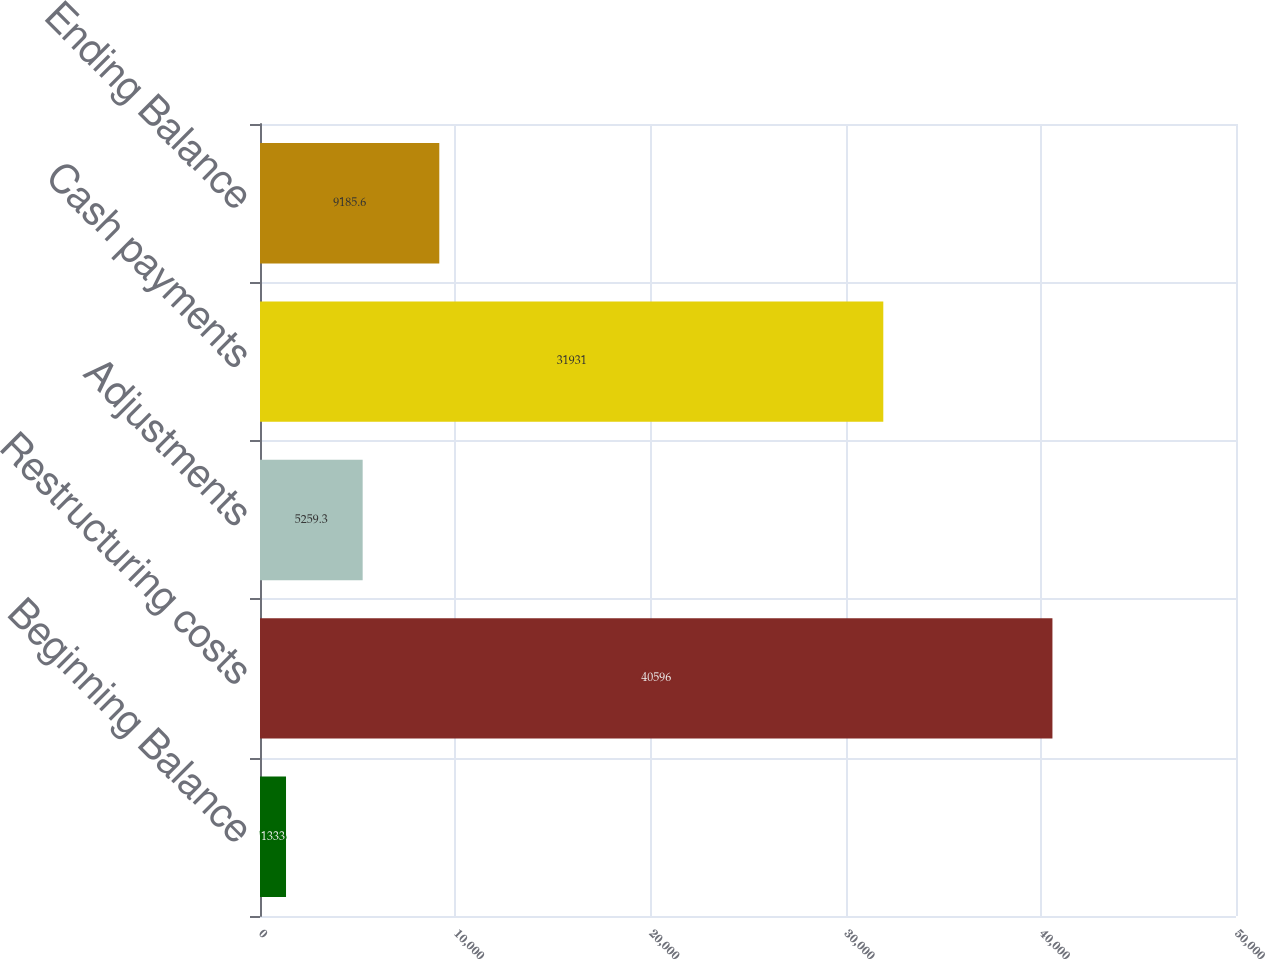Convert chart to OTSL. <chart><loc_0><loc_0><loc_500><loc_500><bar_chart><fcel>Beginning Balance<fcel>Restructuring costs<fcel>Adjustments<fcel>Cash payments<fcel>Ending Balance<nl><fcel>1333<fcel>40596<fcel>5259.3<fcel>31931<fcel>9185.6<nl></chart> 